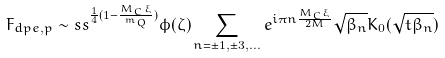Convert formula to latex. <formula><loc_0><loc_0><loc_500><loc_500>F _ { d p e , p } \sim s s ^ { \frac { 1 } { 4 } ( 1 - \frac { M _ { C } \xi } { m _ { Q } } ) } \phi ( \zeta ) \sum _ { n = \pm 1 , \pm 3 , \dots } e ^ { i \pi n \frac { M _ { C } \xi } { 2 M } } \sqrt { \beta _ { n } } K _ { 0 } ( \sqrt { t \beta _ { n } } )</formula> 